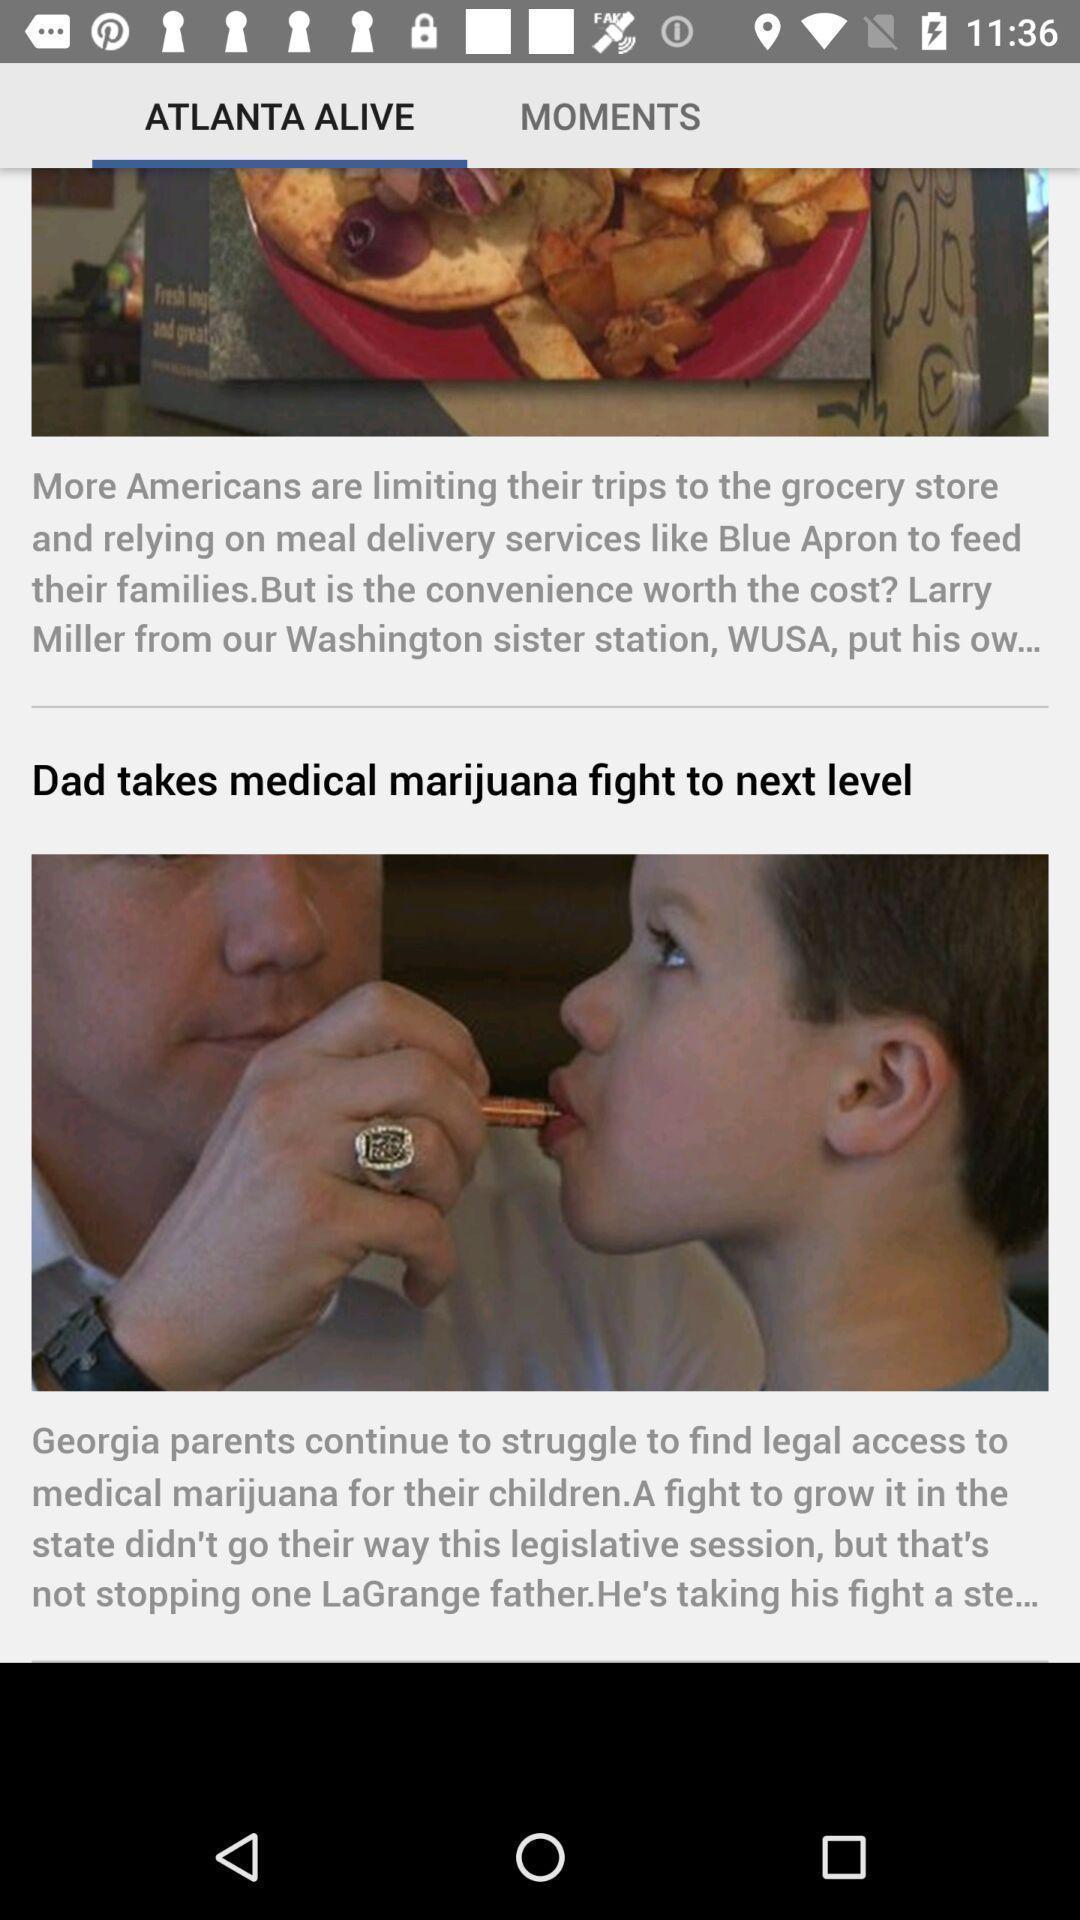Explain the elements present in this screenshot. Screen showing information about the delivery services. 